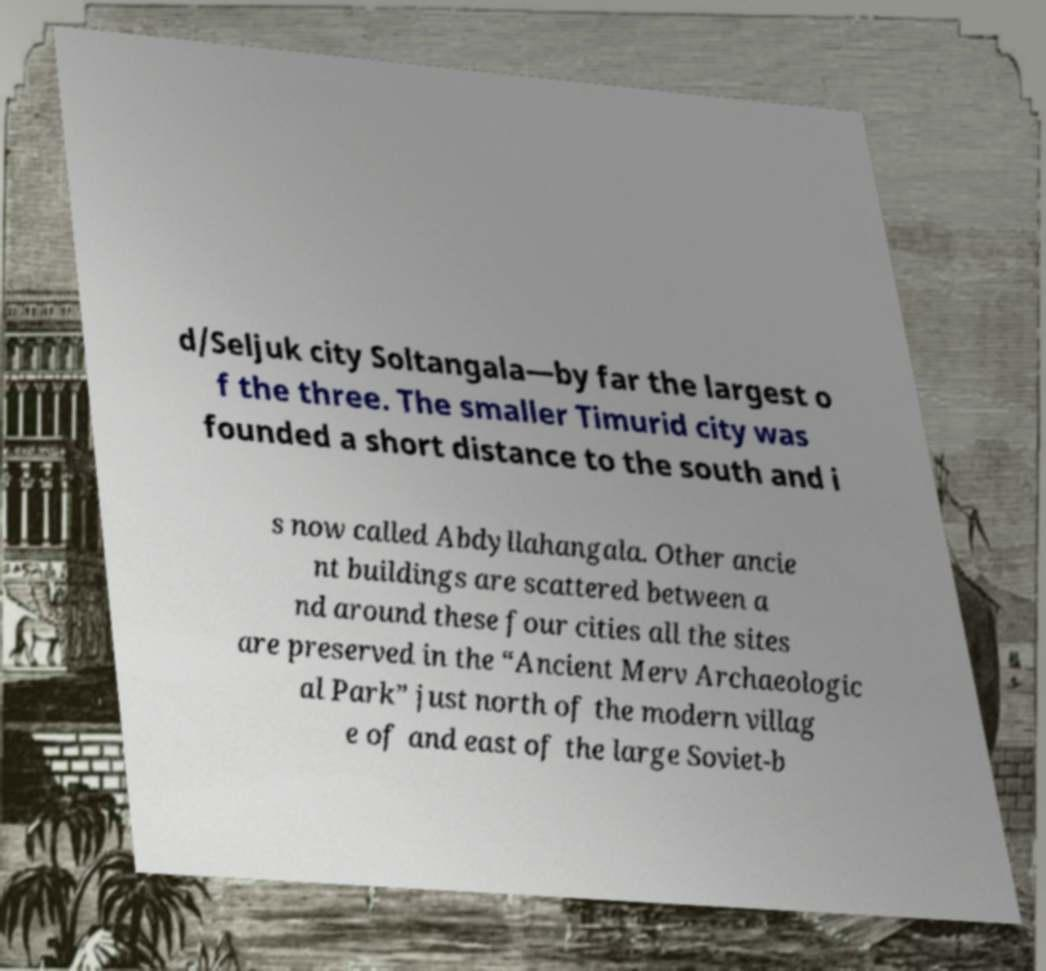For documentation purposes, I need the text within this image transcribed. Could you provide that? d/Seljuk city Soltangala—by far the largest o f the three. The smaller Timurid city was founded a short distance to the south and i s now called Abdyllahangala. Other ancie nt buildings are scattered between a nd around these four cities all the sites are preserved in the “Ancient Merv Archaeologic al Park” just north of the modern villag e of and east of the large Soviet-b 